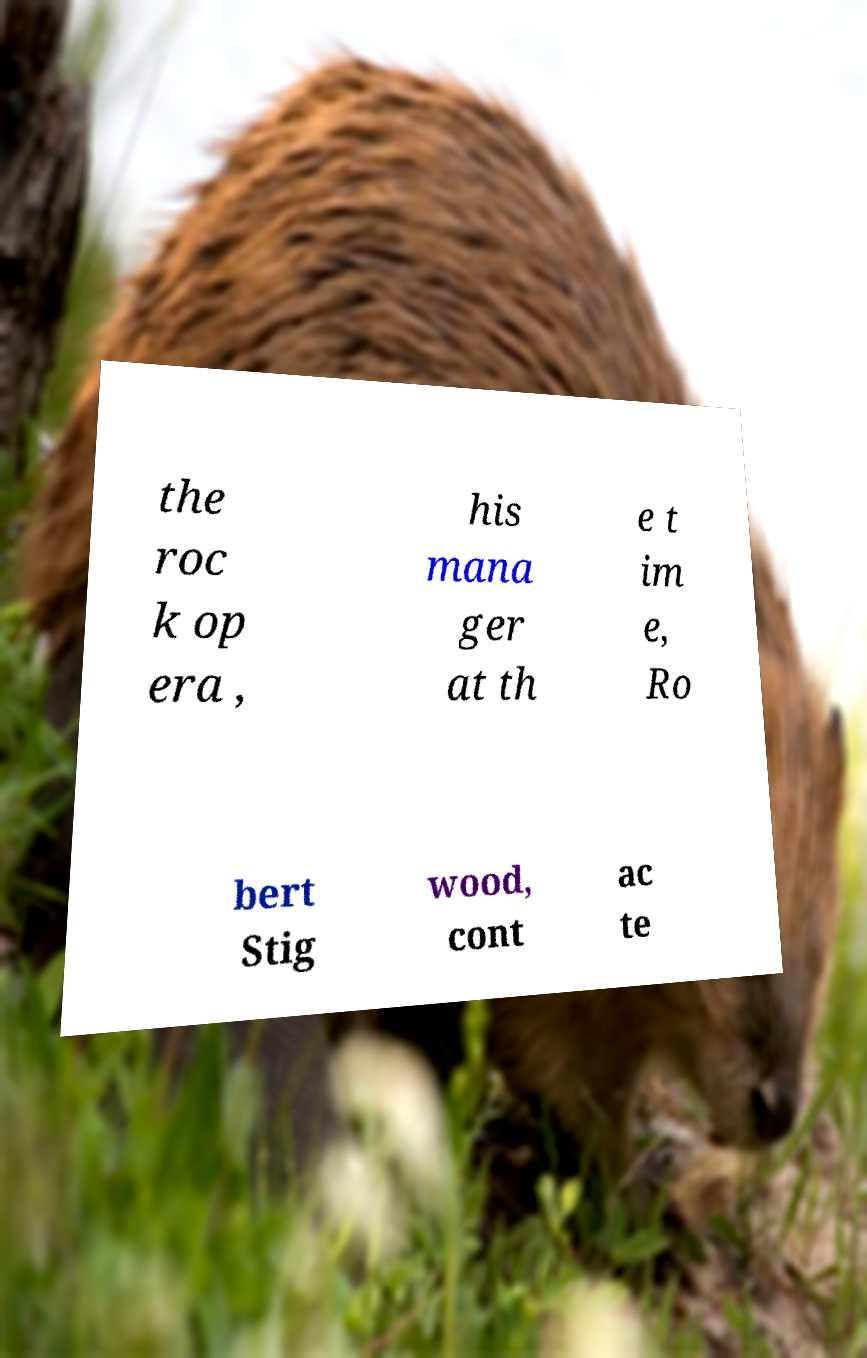Could you assist in decoding the text presented in this image and type it out clearly? the roc k op era , his mana ger at th e t im e, Ro bert Stig wood, cont ac te 